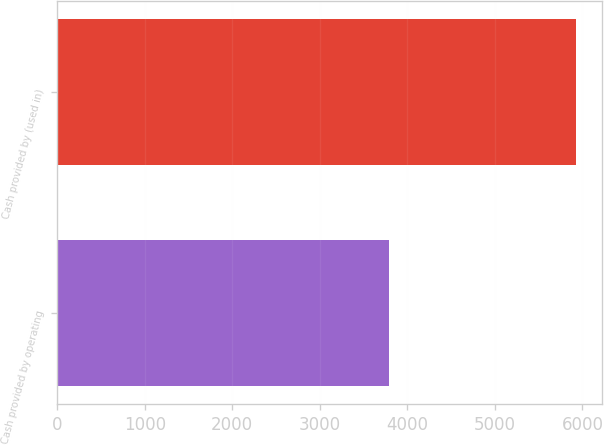Convert chart to OTSL. <chart><loc_0><loc_0><loc_500><loc_500><bar_chart><fcel>Cash provided by operating<fcel>Cash provided by (used in)<nl><fcel>3787<fcel>5928<nl></chart> 